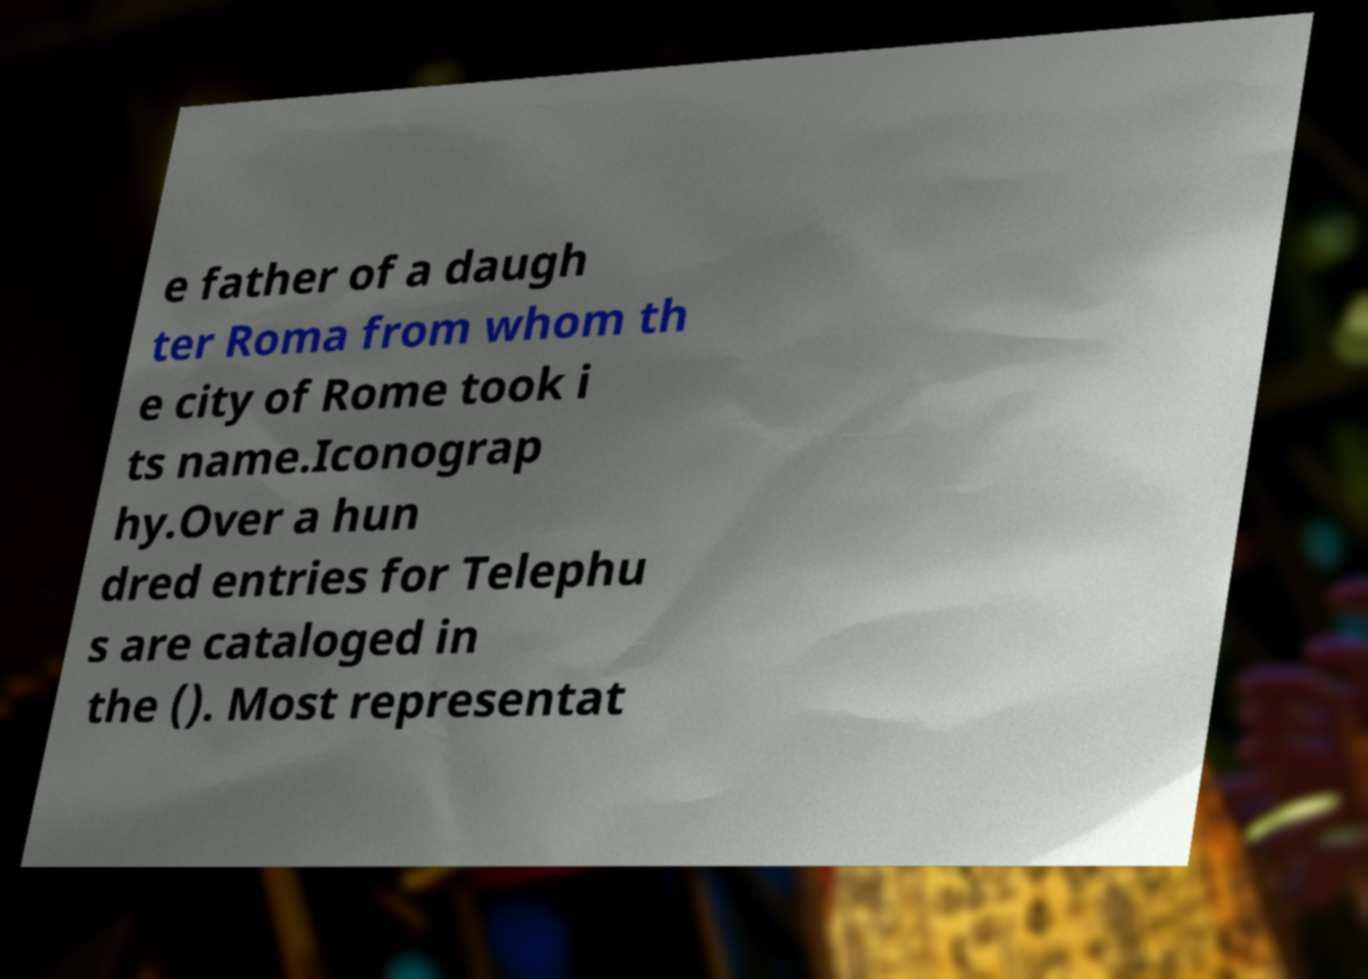For documentation purposes, I need the text within this image transcribed. Could you provide that? e father of a daugh ter Roma from whom th e city of Rome took i ts name.Iconograp hy.Over a hun dred entries for Telephu s are cataloged in the (). Most representat 